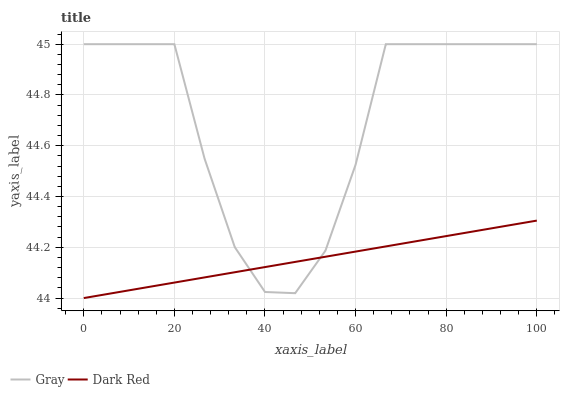Does Dark Red have the minimum area under the curve?
Answer yes or no. Yes. Does Gray have the maximum area under the curve?
Answer yes or no. Yes. Does Dark Red have the maximum area under the curve?
Answer yes or no. No. Is Dark Red the smoothest?
Answer yes or no. Yes. Is Gray the roughest?
Answer yes or no. Yes. Is Dark Red the roughest?
Answer yes or no. No. Does Gray have the highest value?
Answer yes or no. Yes. Does Dark Red have the highest value?
Answer yes or no. No. 